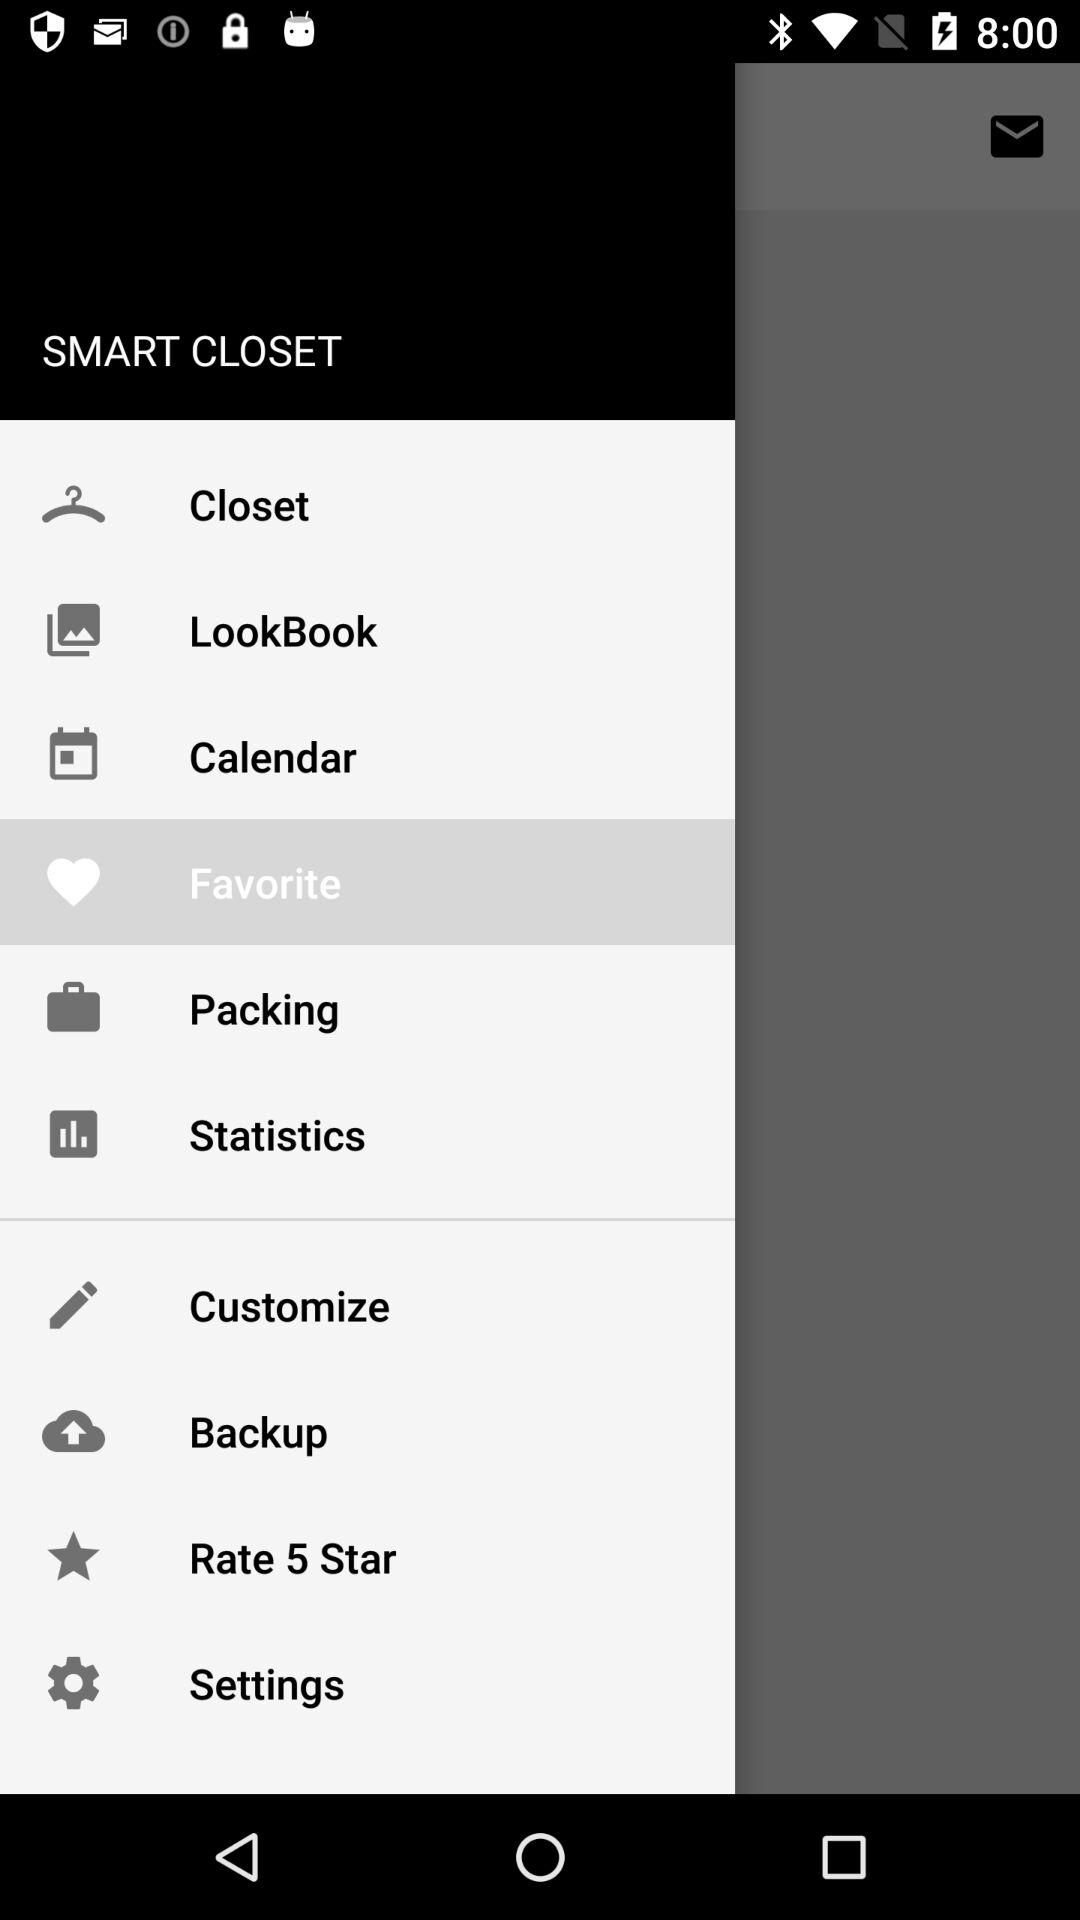Which item is selected in the menu? The selected item is "Favorite". 